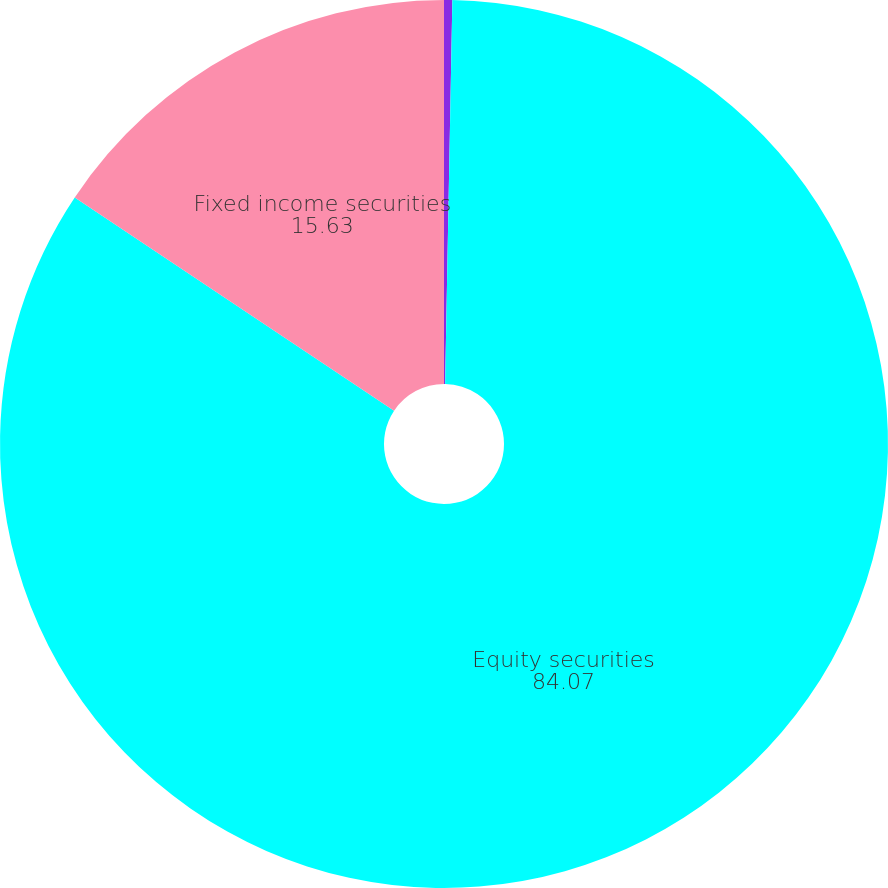Convert chart. <chart><loc_0><loc_0><loc_500><loc_500><pie_chart><fcel>Cash equivalents<fcel>Equity securities<fcel>Fixed income securities<nl><fcel>0.3%<fcel>84.07%<fcel>15.63%<nl></chart> 